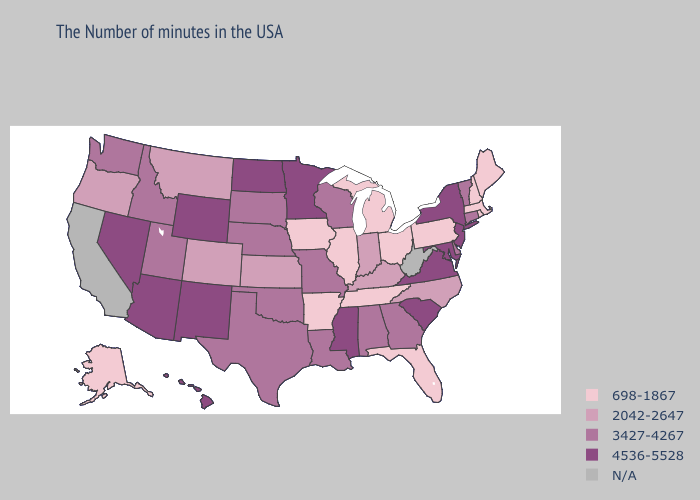Does the map have missing data?
Be succinct. Yes. What is the lowest value in the Northeast?
Be succinct. 698-1867. What is the highest value in the South ?
Keep it brief. 4536-5528. How many symbols are there in the legend?
Quick response, please. 5. Does Mississippi have the highest value in the South?
Keep it brief. Yes. Which states have the lowest value in the West?
Answer briefly. Alaska. Name the states that have a value in the range 2042-2647?
Concise answer only. North Carolina, Kentucky, Indiana, Kansas, Colorado, Montana, Oregon. Name the states that have a value in the range 4536-5528?
Be succinct. New York, New Jersey, Maryland, Virginia, South Carolina, Mississippi, Minnesota, North Dakota, Wyoming, New Mexico, Arizona, Nevada, Hawaii. Name the states that have a value in the range 3427-4267?
Be succinct. Vermont, Connecticut, Delaware, Georgia, Alabama, Wisconsin, Louisiana, Missouri, Nebraska, Oklahoma, Texas, South Dakota, Utah, Idaho, Washington. Name the states that have a value in the range 698-1867?
Short answer required. Maine, Massachusetts, Rhode Island, New Hampshire, Pennsylvania, Ohio, Florida, Michigan, Tennessee, Illinois, Arkansas, Iowa, Alaska. What is the value of Utah?
Quick response, please. 3427-4267. Among the states that border Idaho , does Washington have the highest value?
Answer briefly. No. Does Indiana have the highest value in the MidWest?
Quick response, please. No. Which states have the highest value in the USA?
Answer briefly. New York, New Jersey, Maryland, Virginia, South Carolina, Mississippi, Minnesota, North Dakota, Wyoming, New Mexico, Arizona, Nevada, Hawaii. 